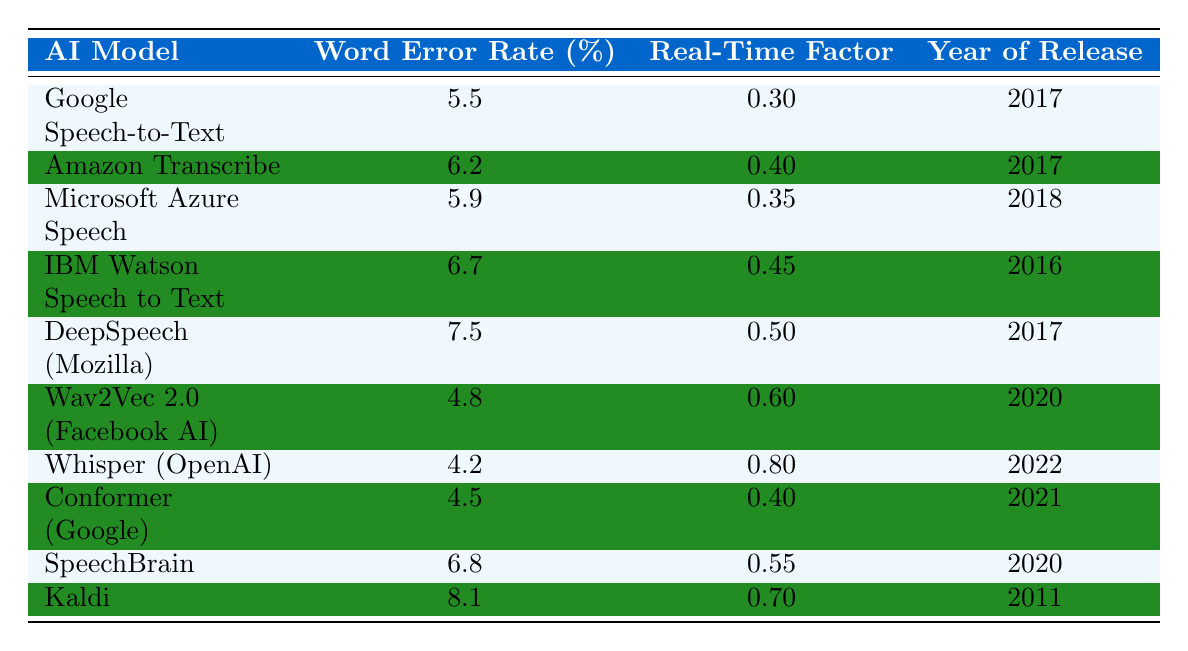What is the Word Error Rate of Whisper (OpenAI)? The table lists the Word Error Rate for each AI model. By locating Whisper (OpenAI) in the first column, we find that its Word Error Rate is recorded as 4.2%.
Answer: 4.2% Which AI model has the highest Word Error Rate? To identify the highest Word Error Rate, we look through the values in the second column. Kaldi has the highest value at 8.1%.
Answer: Kaldi What is the average Word Error Rate for models released in 2017? The models released in 2017 are: Google Speech-to-Text (5.5%), Amazon Transcribe (6.2%), DeepSpeech (Mozilla) (7.5%). To calculate the average, we sum these values: 5.5 + 6.2 + 7.5 = 19.2, then divide by 3 (the number of models): 19.2 / 3 = 6.4%.
Answer: 6.4% Is the Real-Time Factor for Wav2Vec 2.0 (Facebook AI) less than 0.7? The Real-Time Factor for Wav2Vec 2.0 (Facebook AI) is listed as 0.6, which is indeed less than 0.7. Therefore, this statement is true.
Answer: Yes How many AI models have a Word Error Rate lower than 5.5%? We examine the Word Error Rates in the second column. Beyond Google Speech-to-Text (5.5%), we find that Whisper (OpenAI) (4.2%) and Wav2Vec 2.0 (Facebook AI) (4.8%) have lower rates. Thus, there are 2 models with a lower Word Error Rate.
Answer: 2 What is the Real-Time Factor difference between the best and worst AI models? The best (Whisper with 0.8) and worst (Kaldi with 0.7) Real-Time Factors are looked at. The difference is calculated by subtracting 0.7 from 0.8, resulting in a difference of 0.1.
Answer: 0.1 Which model was released first in 2016? The table indicates that IBM Watson Speech to Text is listed under the year 2016, confirming it as the model released first in that year.
Answer: IBM Watson Speech to Text Which models have a Real-Time Factor greater than 0.5? We can see that the models with Real-Time Factors greater than 0.5 are Wav2Vec 2.0 (0.6), Whisper (0.8), and Kaldi (0.7). This totals to 3 models.
Answer: 3 